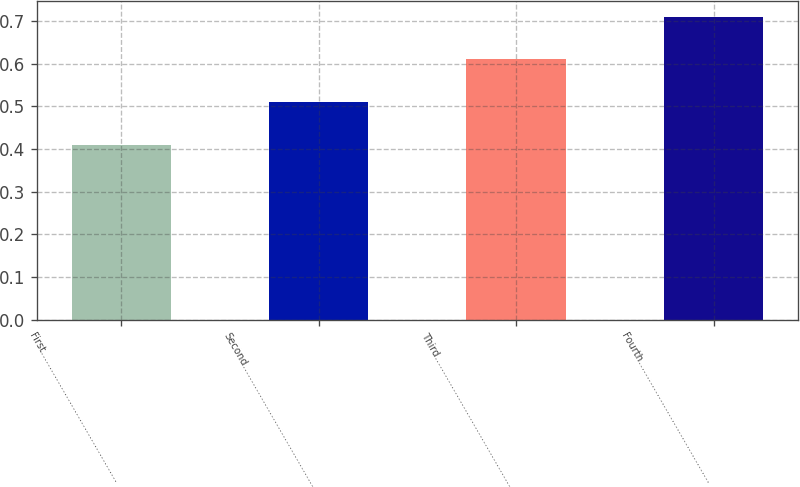Convert chart to OTSL. <chart><loc_0><loc_0><loc_500><loc_500><bar_chart><fcel>First………………………………………<fcel>Second……………………………………<fcel>Third………………………………………<fcel>Fourth……………………………………<nl><fcel>0.41<fcel>0.51<fcel>0.61<fcel>0.71<nl></chart> 